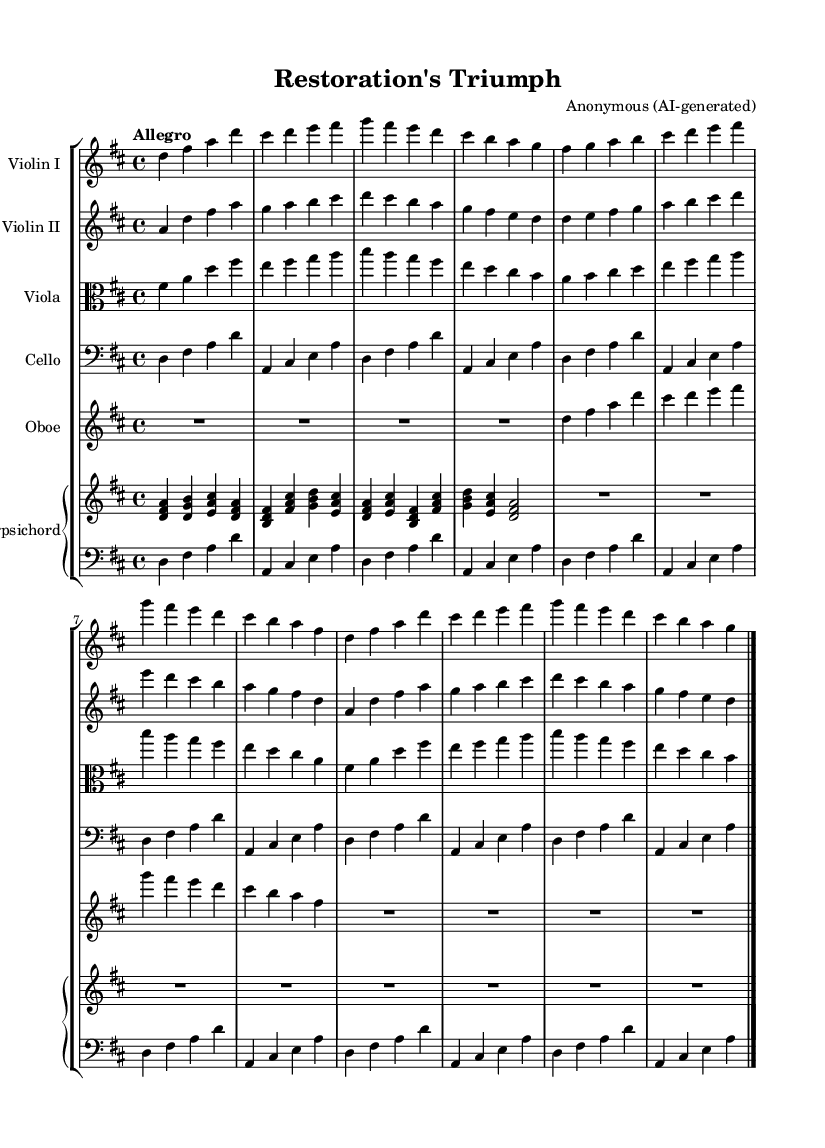What is the key signature of this music? The key signature is indicated at the beginning of the staff with sharps or flats. In this sheet music, it's marked with two sharps, indicating that the key is D major.
Answer: D major What is the time signature of this piece? The time signature is shown at the beginning of the staff, where it is written as 4/4, meaning there are four beats in a measure and the quarter note gets one beat.
Answer: 4/4 What is the tempo marking for this piece? The tempo marking is found above the staff and is marked as "Allegro," which indicates a fast and lively tempo.
Answer: Allegro How many different instruments are used in this composition? The sheet music shows multiple staff sections, each labeled with an instrument name. Counting them, we see Violin I, Violin II, Viola, Cello, Oboe, and Harpsichord, totaling six instruments.
Answer: Six Which instrument is specified to play in alto clef? The viola part is indicated to be read in alto clef, which is specifically designed for instruments like the viola that frequently play in a middle range.
Answer: Viola What type of texture is predominantly used in this piece? By analyzing the music, we notice multiple instrumental parts interweaving melodically, which suggests a polyphonic texture typical of Baroque music, where multiple independent melodies are played simultaneously.
Answer: Polyphonic What is the last note played by the cello? The last note in the cello part is identified by looking at the final measure, which is marked with a barline indicating the end of the piece. The last note is A in the bass clef.
Answer: A 